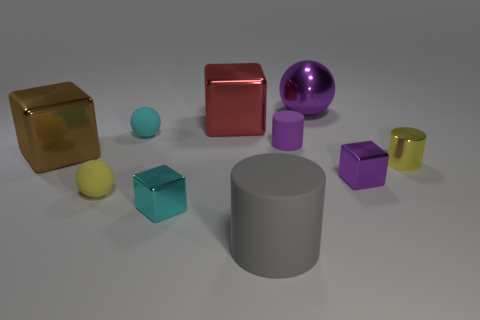Subtract all red cylinders. Subtract all brown blocks. How many cylinders are left? 3 Subtract all blocks. How many objects are left? 6 Add 8 tiny purple metal cylinders. How many tiny purple metal cylinders exist? 8 Subtract 0 brown spheres. How many objects are left? 10 Subtract all gray objects. Subtract all purple metal spheres. How many objects are left? 8 Add 2 large balls. How many large balls are left? 3 